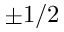Convert formula to latex. <formula><loc_0><loc_0><loc_500><loc_500>\pm 1 / 2</formula> 